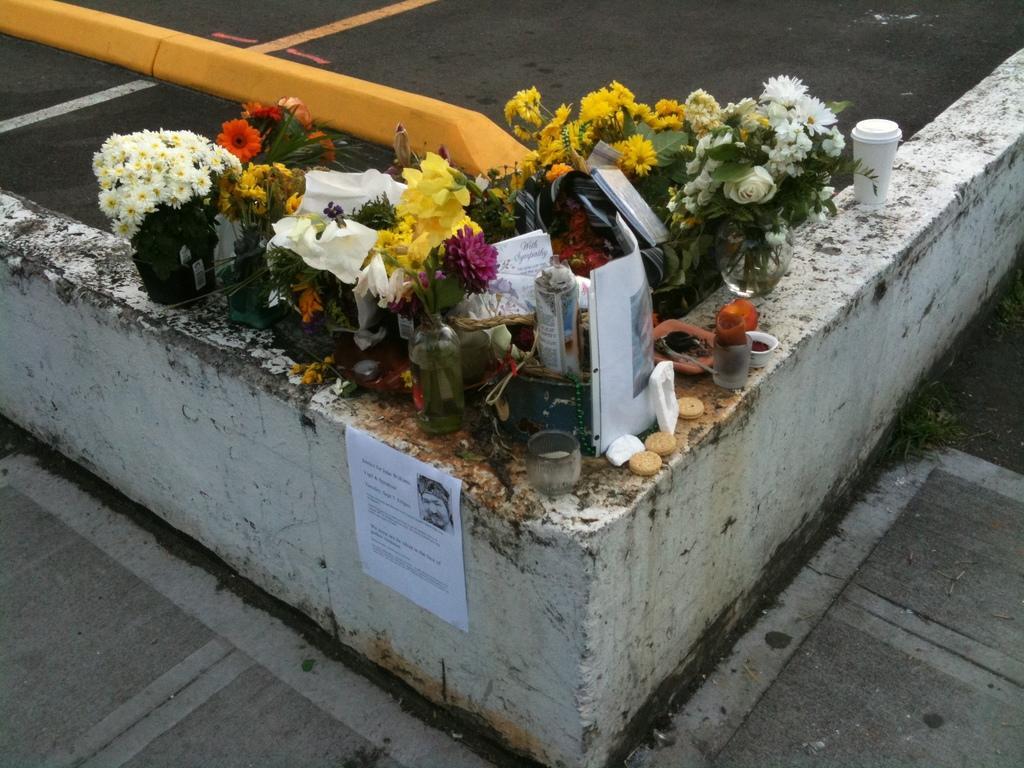Please provide a concise description of this image. In this image, we can see flower vases, flower pots, biscuits, glasses, papers, books are placed on the wall and we can see a poster pasted on it. At the bottom, there is road. 